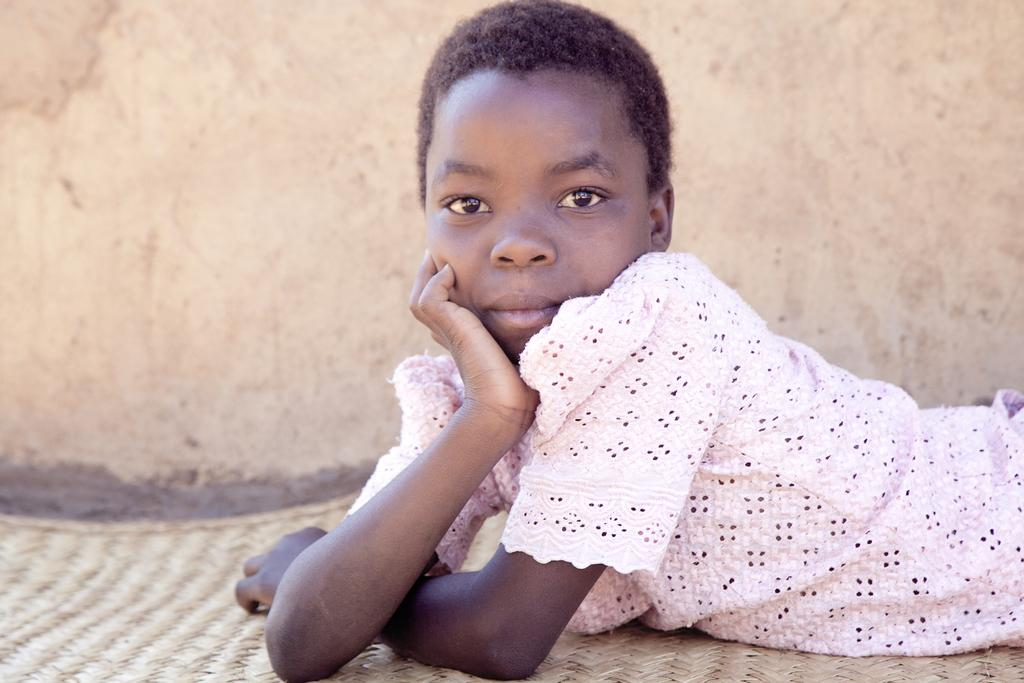What is the main subject of the image? The main subject of the image is a girl. What is the girl wearing in the image? The girl is wearing a pink shirt. What is the girl's position in the image? The girl is laying on the floor. What can be seen in the background of the image? There is a wall visible in the background of the image. How does the girl's sneeze affect the value of the stock market in the image? There is no reference to the stock market or a sneeze in the image, so it's not possible to determine any effect on the stock market. 